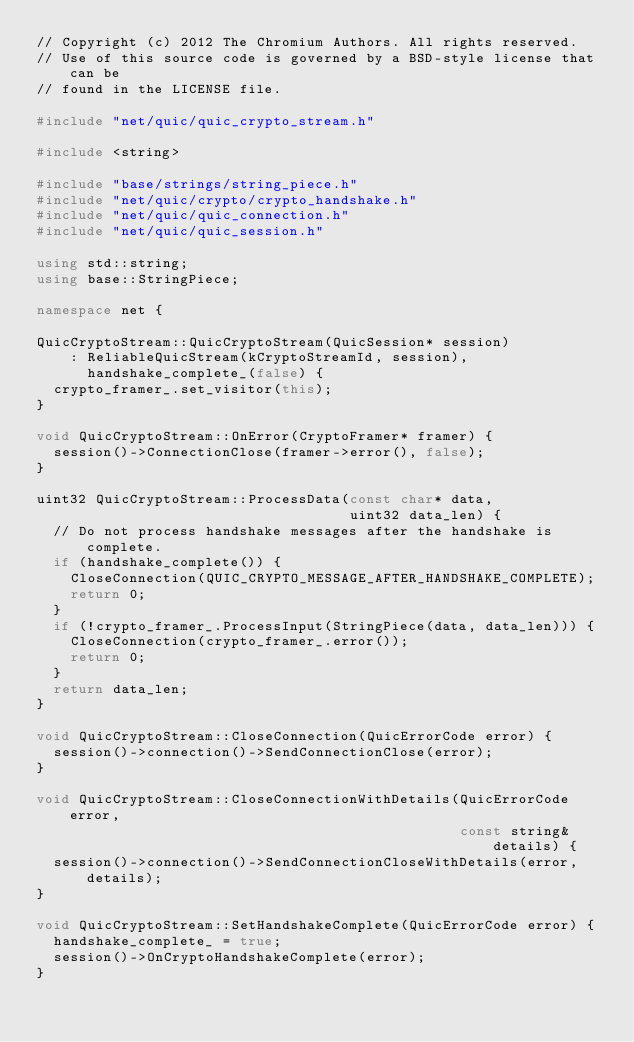Convert code to text. <code><loc_0><loc_0><loc_500><loc_500><_C++_>// Copyright (c) 2012 The Chromium Authors. All rights reserved.
// Use of this source code is governed by a BSD-style license that can be
// found in the LICENSE file.

#include "net/quic/quic_crypto_stream.h"

#include <string>

#include "base/strings/string_piece.h"
#include "net/quic/crypto/crypto_handshake.h"
#include "net/quic/quic_connection.h"
#include "net/quic/quic_session.h"

using std::string;
using base::StringPiece;

namespace net {

QuicCryptoStream::QuicCryptoStream(QuicSession* session)
    : ReliableQuicStream(kCryptoStreamId, session),
      handshake_complete_(false) {
  crypto_framer_.set_visitor(this);
}

void QuicCryptoStream::OnError(CryptoFramer* framer) {
  session()->ConnectionClose(framer->error(), false);
}

uint32 QuicCryptoStream::ProcessData(const char* data,
                                     uint32 data_len) {
  // Do not process handshake messages after the handshake is complete.
  if (handshake_complete()) {
    CloseConnection(QUIC_CRYPTO_MESSAGE_AFTER_HANDSHAKE_COMPLETE);
    return 0;
  }
  if (!crypto_framer_.ProcessInput(StringPiece(data, data_len))) {
    CloseConnection(crypto_framer_.error());
    return 0;
  }
  return data_len;
}

void QuicCryptoStream::CloseConnection(QuicErrorCode error) {
  session()->connection()->SendConnectionClose(error);
}

void QuicCryptoStream::CloseConnectionWithDetails(QuicErrorCode error,
                                                  const string& details) {
  session()->connection()->SendConnectionCloseWithDetails(error, details);
}

void QuicCryptoStream::SetHandshakeComplete(QuicErrorCode error) {
  handshake_complete_ = true;
  session()->OnCryptoHandshakeComplete(error);
}
</code> 